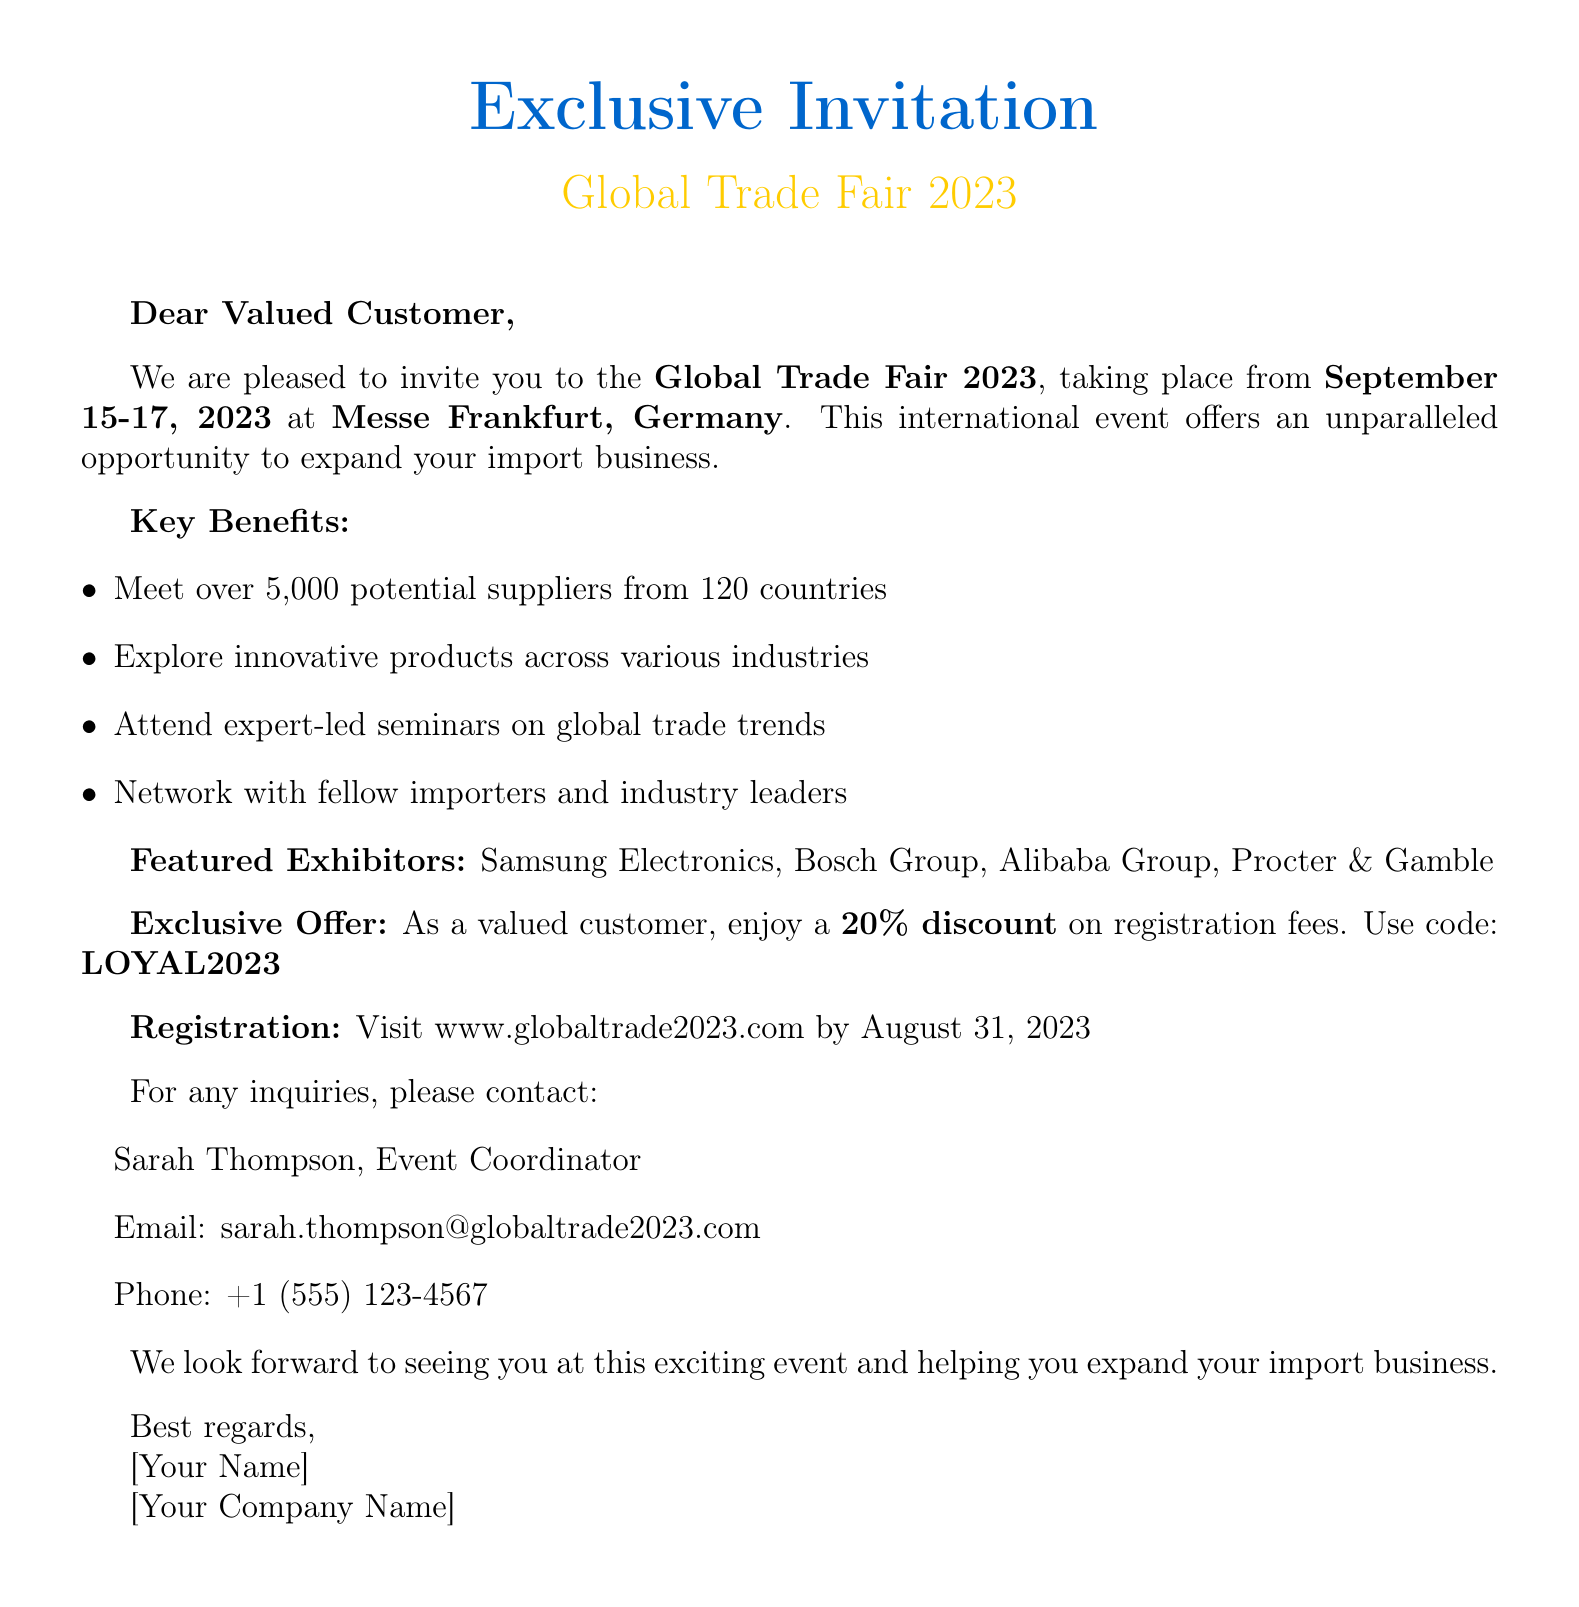What is the event name? The event name is explicitly mentioned in the introduction section of the document as the Global Trade Fair 2023.
Answer: Global Trade Fair 2023 What are the event dates? The dates for the event are provided in the introduction section as September 15-17, 2023.
Answer: September 15-17, 2023 Where is the event located? The location of the event is clearly stated in the introduction as Messe Frankfurt, Germany.
Answer: Messe Frankfurt, Germany How many suppliers will be present? The document states that there will be over 5,000 potential suppliers at the event.
Answer: over 5,000 What discount is offered to loyal customers? The document specifies a 20% discount for loyal customers in the exclusive offer section.
Answer: 20% off What is the registration deadline? The registration deadline is mentioned in the registration details section as August 31, 2023.
Answer: August 31, 2023 Who should inquiries be directed to? The contact person named for inquiries is Sarah Thompson, as listed in the contact section.
Answer: Sarah Thompson What is the registration website? The website for registration is provided in the registration details section as www.globaltrade2023.com.
Answer: www.globaltrade2023.com Which country is Samsung Electronics from? The document lists Samsung Electronics as an exhibitor and notes it is from South Korea.
Answer: South Korea 